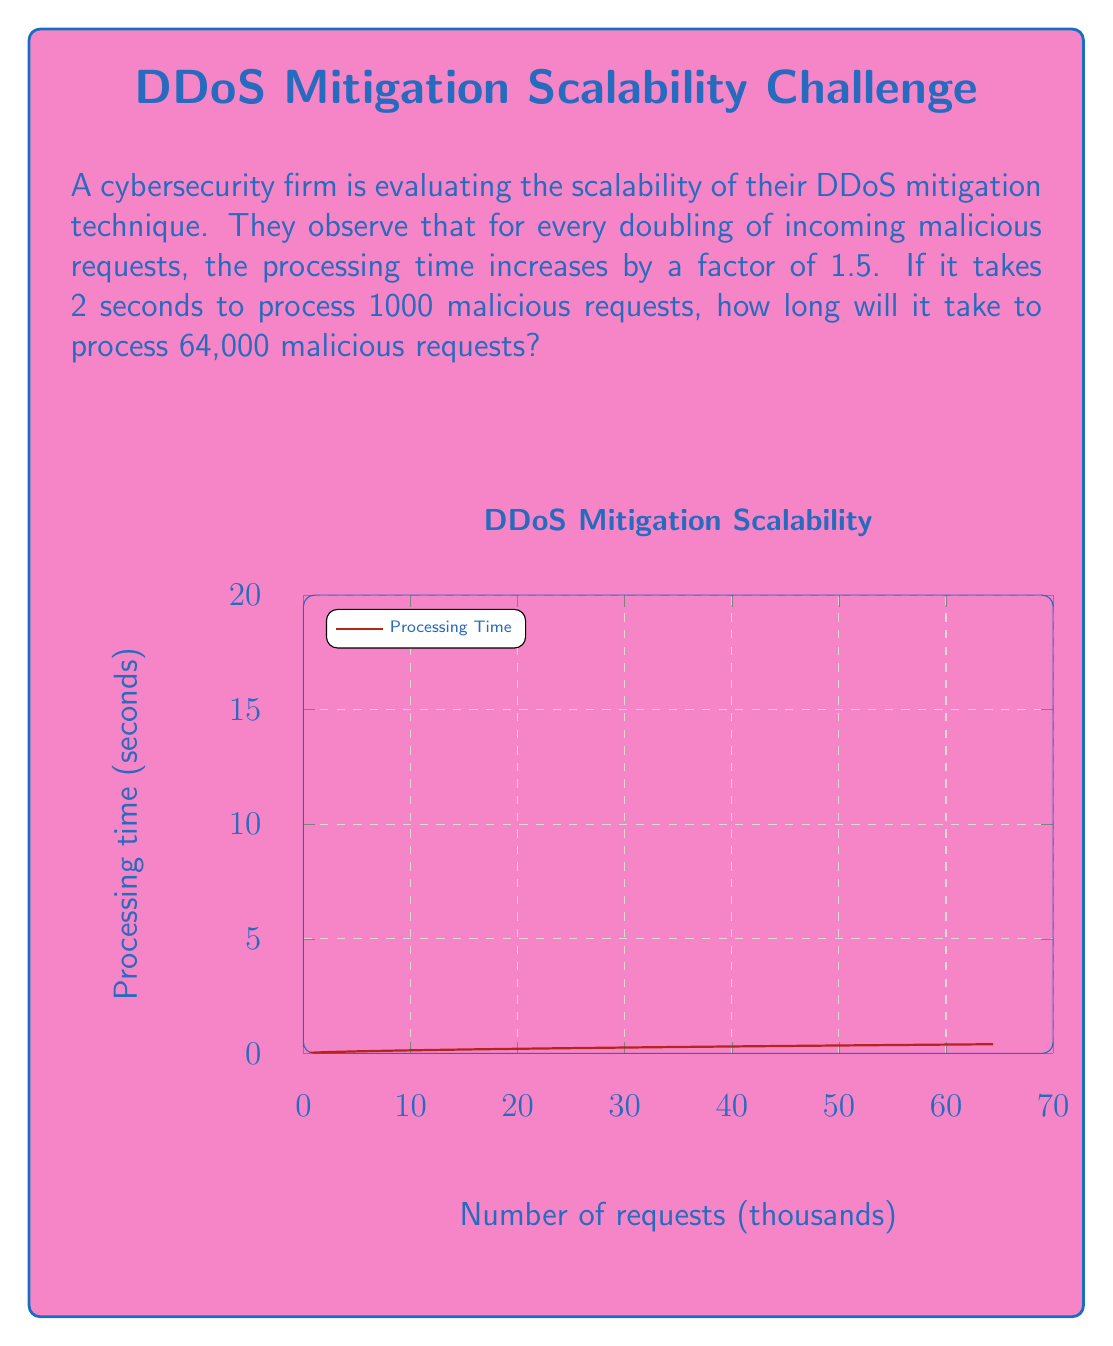Could you help me with this problem? Let's approach this step-by-step:

1) First, we need to determine how many times the number of requests doubles from 1000 to 64,000.

   $64000 = 1000 * 2^n$
   $2^6 = 2^n$
   $n = 6$

   So, the number of requests doubles 6 times.

2) Now, we know that each time the requests double, the processing time increases by a factor of 1.5.

3) We can express this as:

   $T = 2 * 1.5^6$

   Where T is the final processing time, 2 is the initial processing time, and 1.5 is raised to the power of 6 (the number of doublings).

4) Let's calculate:

   $T = 2 * 1.5^6$
   $T = 2 * (1.5 * 1.5 * 1.5 * 1.5 * 1.5 * 1.5)$
   $T = 2 * 11.390625$
   $T = 22.78125$

5) Therefore, it will take approximately 22.78 seconds to process 64,000 malicious requests.
Answer: $22.78$ seconds 